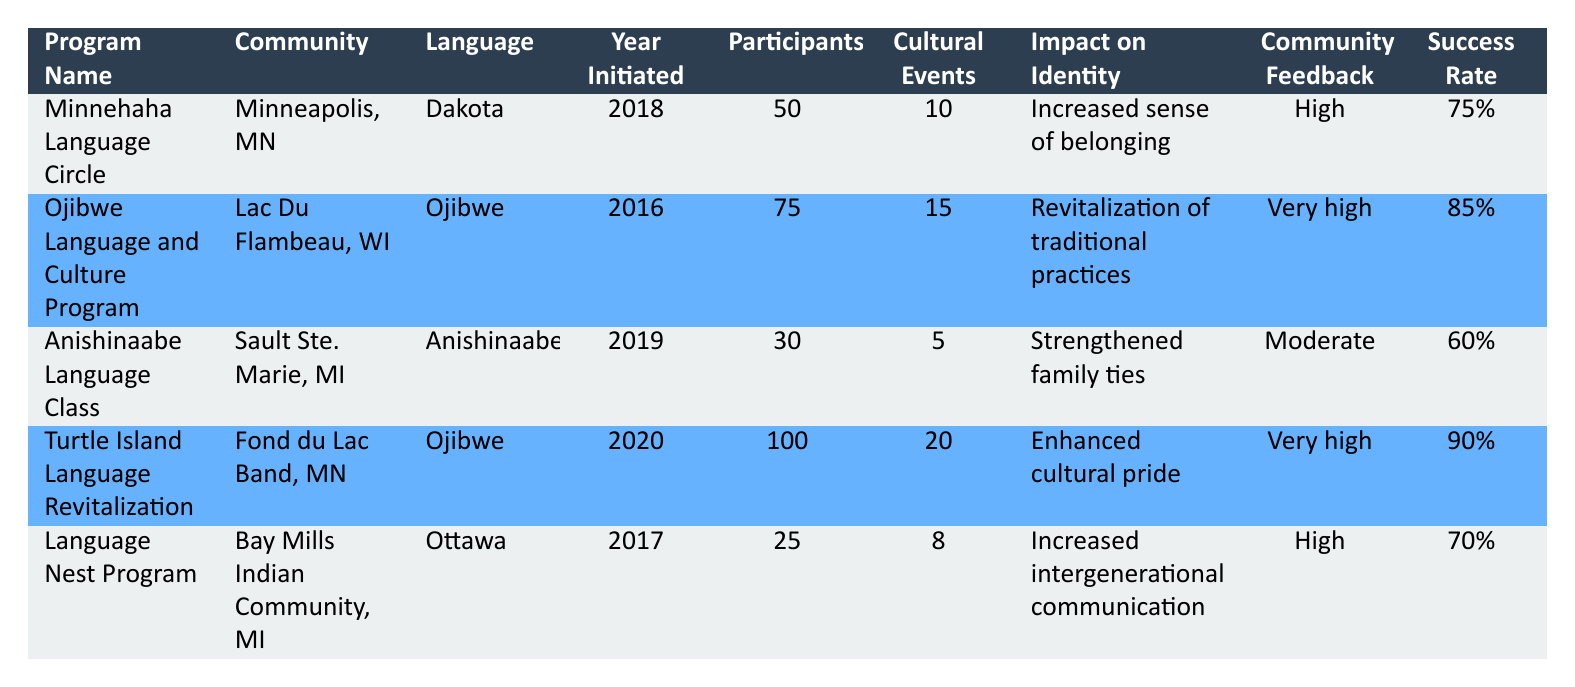What is the community with the highest number of participants engaged? The table lists the number of participants engaged for each program. By comparing the values, "Turtle Island Language Revitalization" has the highest number of participants, which is 100.
Answer: Fond du Lac Band, MN Which language is associated with the program that received "very high" community feedback? The table shows that both the "Ojibwe Language and Culture Program" and the "Turtle Island Language Revitalization" received "very high" community feedback. Both programs are associated with the Ojibwe language.
Answer: Ojibwe What is the average success rate of all language revitalization programs listed? To find the average success rate, we will convert percentages to decimal form and sum them up: 0.75 + 0.85 + 0.60 + 0.90 + 0.70 = 3.70. Then, divide by the number of programs (5): 3.70 / 5 = 0.74. Converting back to percentage gives us an average success rate of 74%.
Answer: 74% Did any of the programs focus on the Ottawa language? By reviewing the language column, the "Language Nest Program" specifically mentions the Ottawa language, confirming that there is a program focused on it.
Answer: Yes Which program organized the least number of cultural events? The table indicates the number of cultural events organized for each program. The "Anishinaabe Language Class" organized the least with 5 events.
Answer: Anishinaabe Language Class 